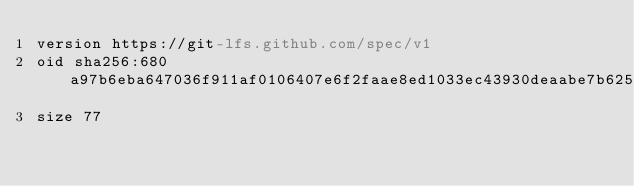<code> <loc_0><loc_0><loc_500><loc_500><_YAML_>version https://git-lfs.github.com/spec/v1
oid sha256:680a97b6eba647036f911af0106407e6f2faae8ed1033ec43930deaabe7b625e
size 77
</code> 